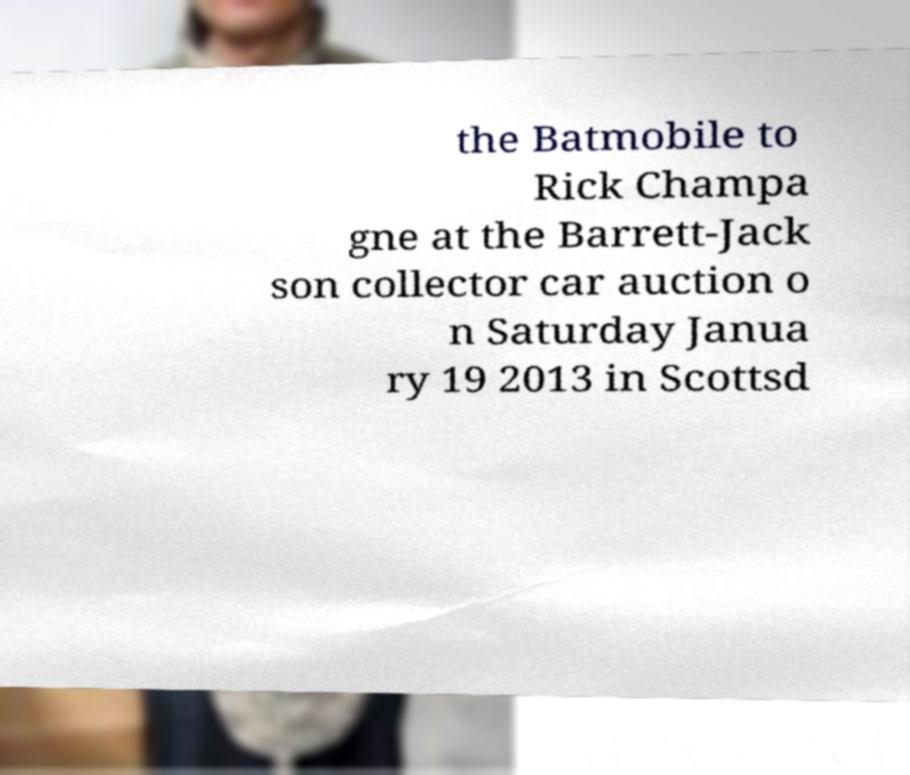Could you assist in decoding the text presented in this image and type it out clearly? the Batmobile to Rick Champa gne at the Barrett-Jack son collector car auction o n Saturday Janua ry 19 2013 in Scottsd 